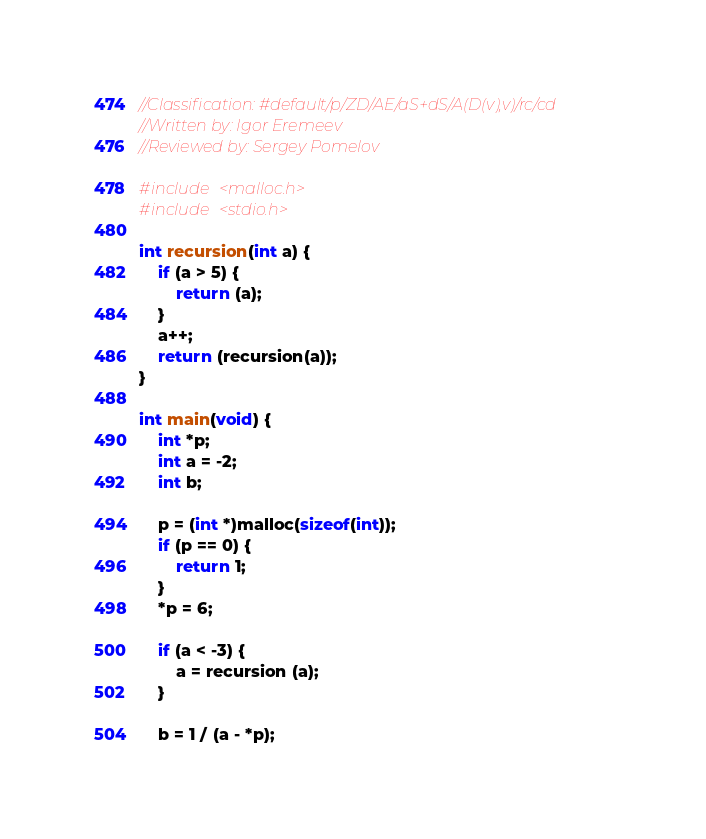Convert code to text. <code><loc_0><loc_0><loc_500><loc_500><_C_>//Classification: #default/p/ZD/AE/aS+dS/A(D(v),v)/rc/cd
//Written by: Igor Eremeev
//Reviewed by: Sergey Pomelov

#include <malloc.h>
#include <stdio.h>

int recursion(int a) {
	if (a > 5) {
		return (a);
	}
	a++;
	return (recursion(a));
}

int main(void) {
	int *p;
	int a = -2;
	int b;
	
	p = (int *)malloc(sizeof(int));
	if (p == 0) {
		return 1;
	}
	*p = 6;
	
	if (a < -3) {
		a = recursion (a);
	}

	b = 1 / (a - *p);</code> 